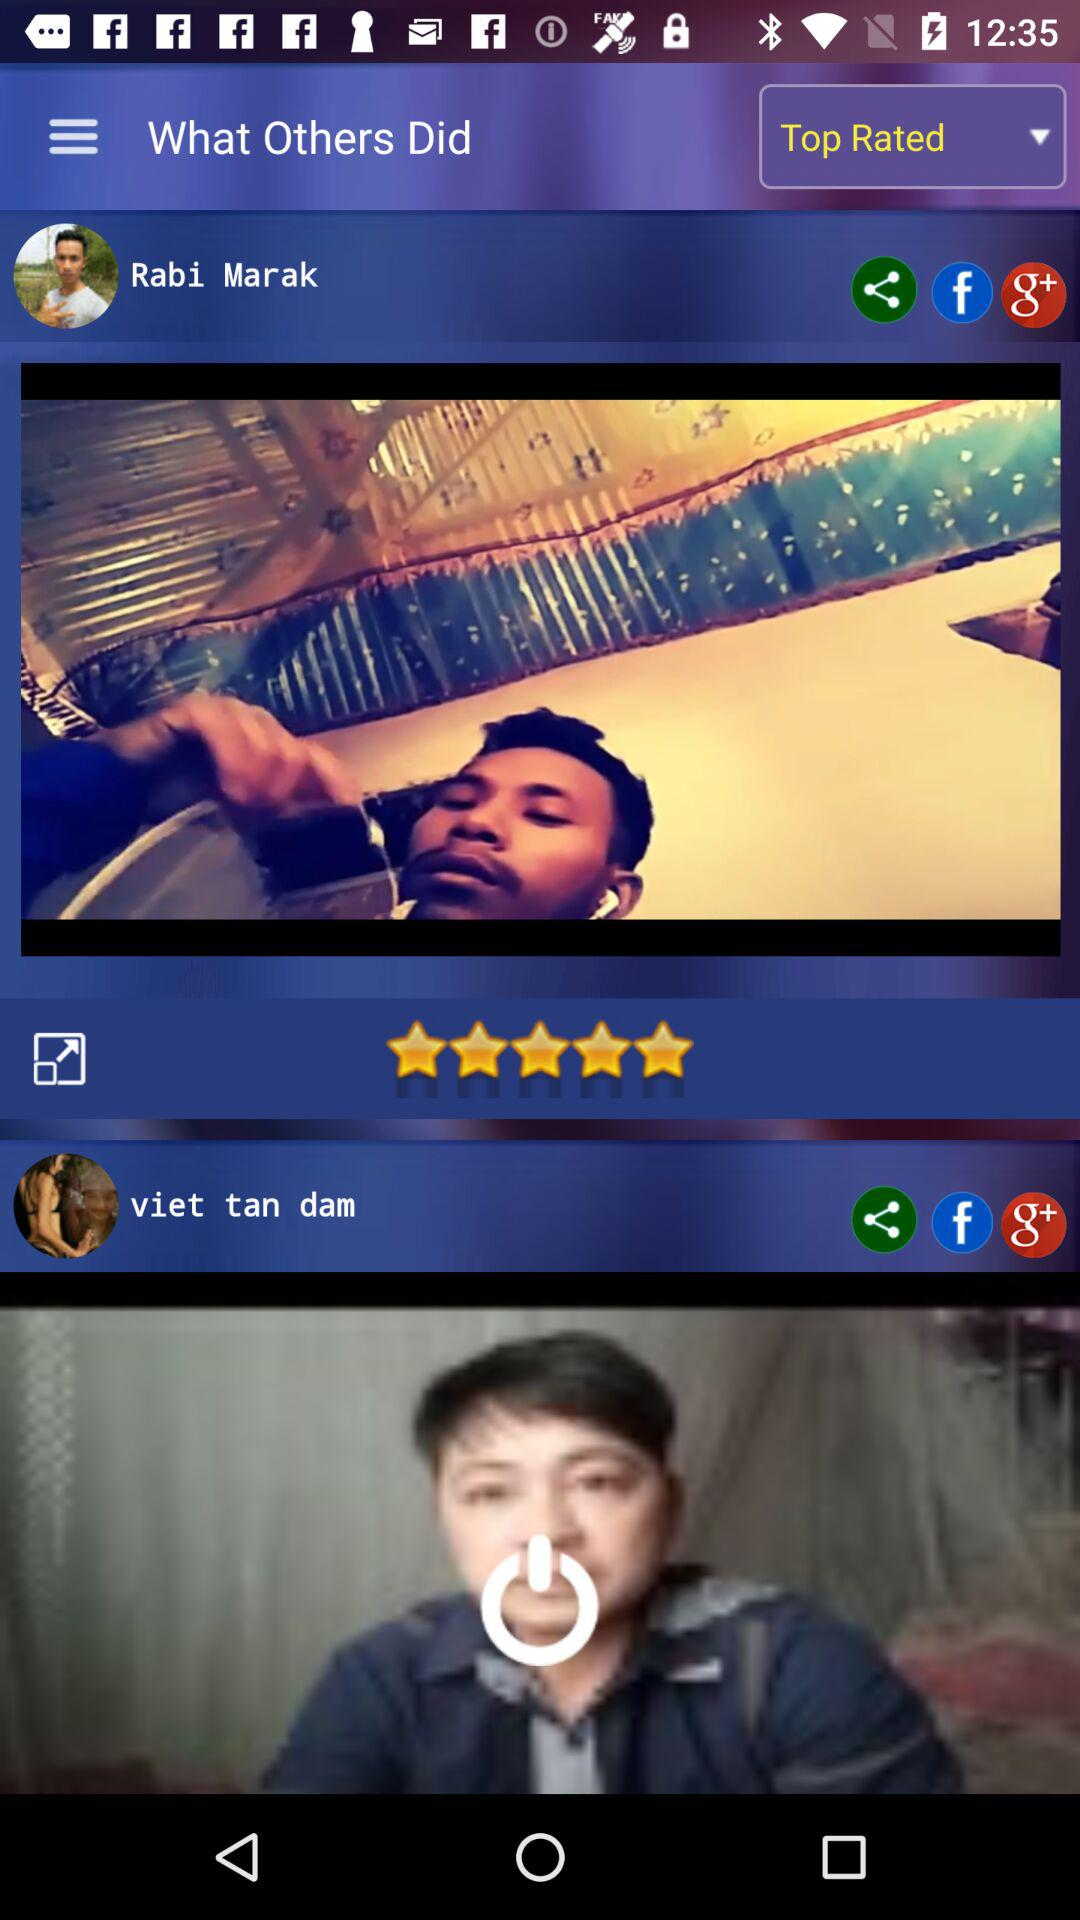What are the options to share a profile? The options are "Facebook" and "Google+". 